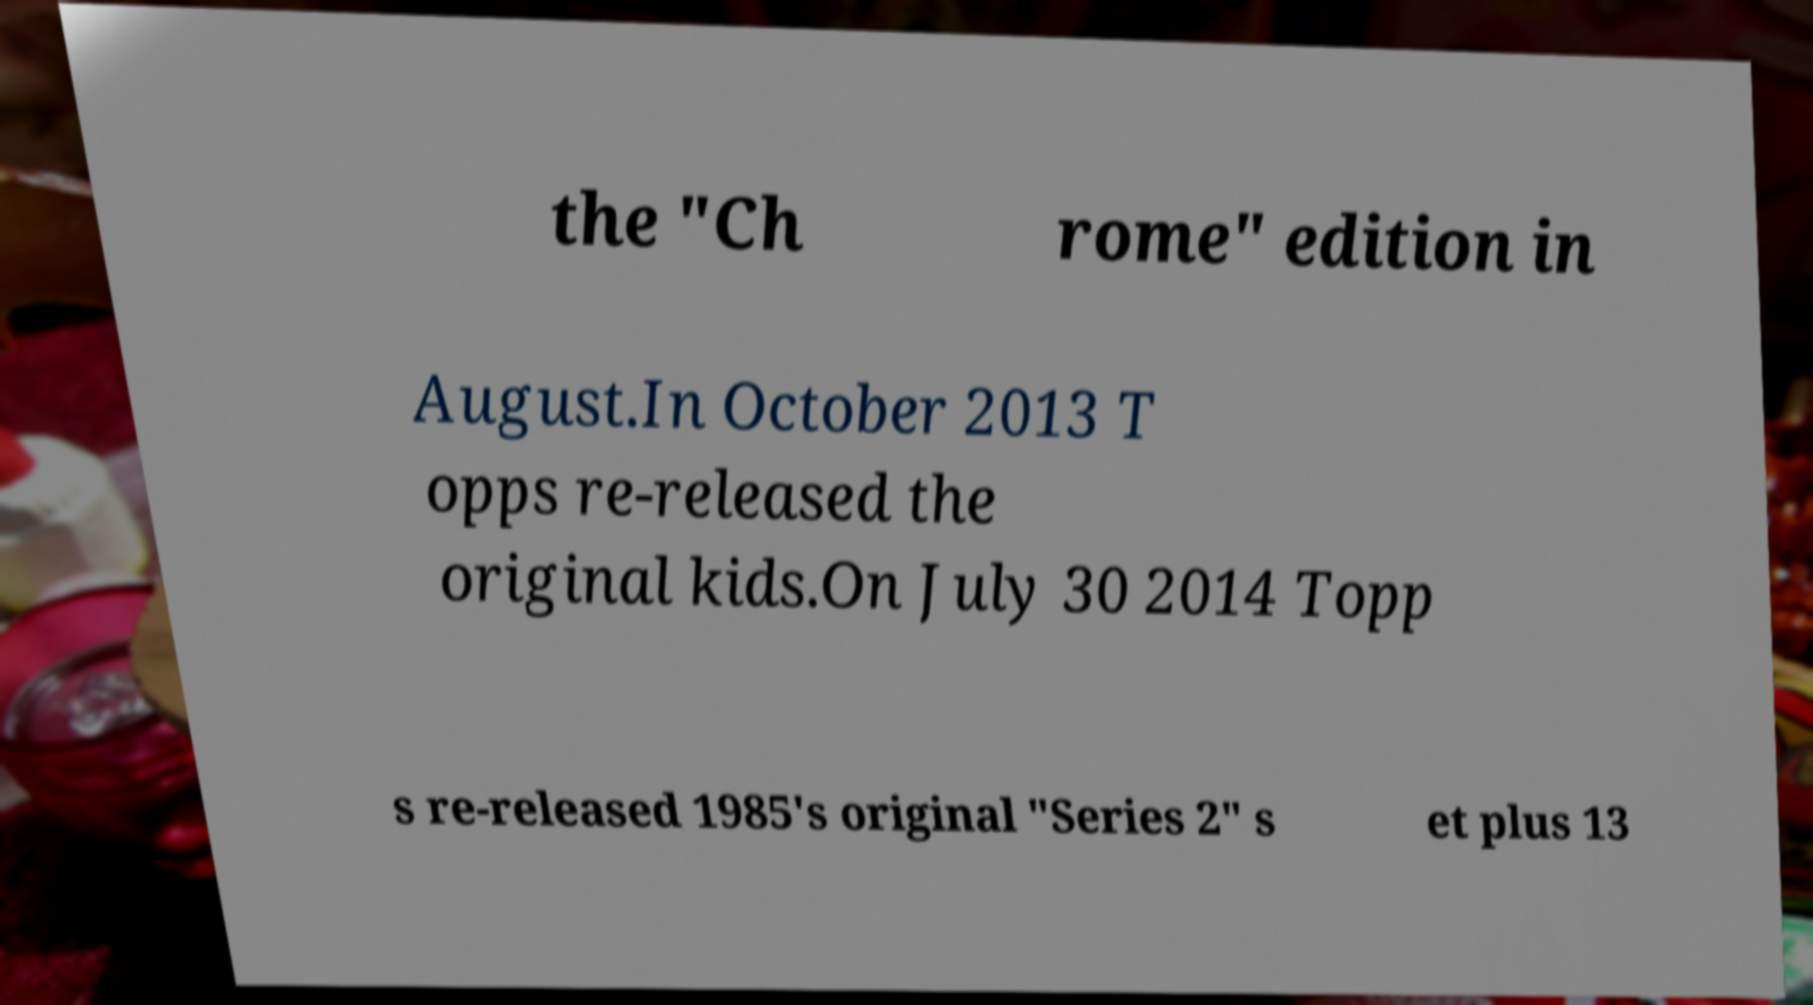Could you assist in decoding the text presented in this image and type it out clearly? the "Ch rome" edition in August.In October 2013 T opps re-released the original kids.On July 30 2014 Topp s re-released 1985's original "Series 2" s et plus 13 